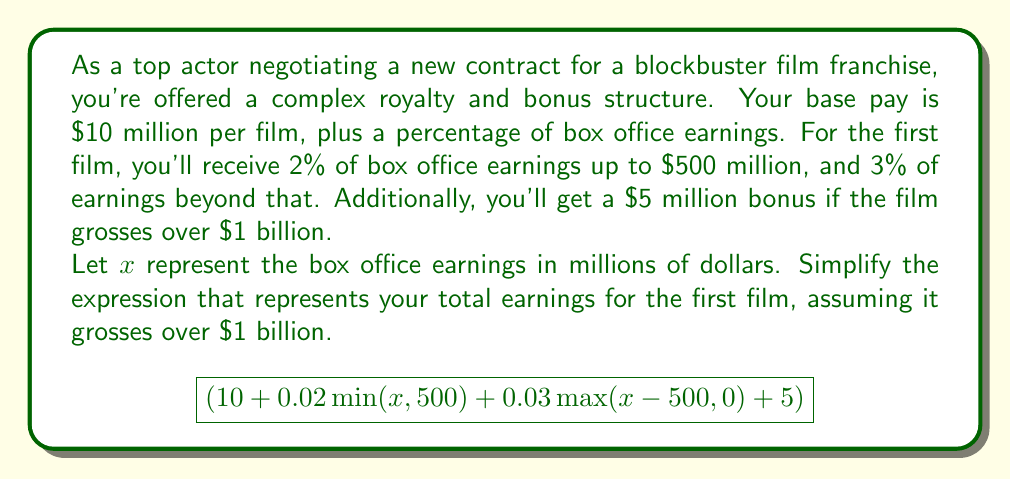Can you answer this question? Let's break this down step by step:

1) First, we know that $x > 1000$ (since the film grosses over $1 billion), so we can simplify some parts of the expression:

   - $\min(x, 500)$ will always be 500
   - $\max(x-500, 0)$ will always be $x-500$

2) Let's substitute these into our expression:

   $$(10 + 0.02(500) + 0.03(x-500) + 5)$$

3) Now, let's simplify the constant terms:
   
   $10 + 0.02(500) = 10 + 10 = 20$
   
   So our expression becomes:

   $$(20 + 0.03(x-500) + 5)$$

4) Simplify inside the parentheses:

   $$(20 + 0.03x - 15 + 5)$$

5) Combine like terms:

   $$(10 + 0.03x)$$

6) This is our simplified expression. It represents your base pay ($10 million), plus 3% of the total box office earnings.
Answer: $10 + 0.03x$ million dollars, where $x$ is the box office earnings in millions. 